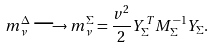Convert formula to latex. <formula><loc_0><loc_0><loc_500><loc_500>m _ { \nu } ^ { \Delta } \longrightarrow m ^ { \Sigma } _ { \nu } = \frac { v ^ { 2 } } { 2 } Y ^ { T } _ { \Sigma } M ^ { - 1 } _ { \Sigma } Y _ { \Sigma } .</formula> 